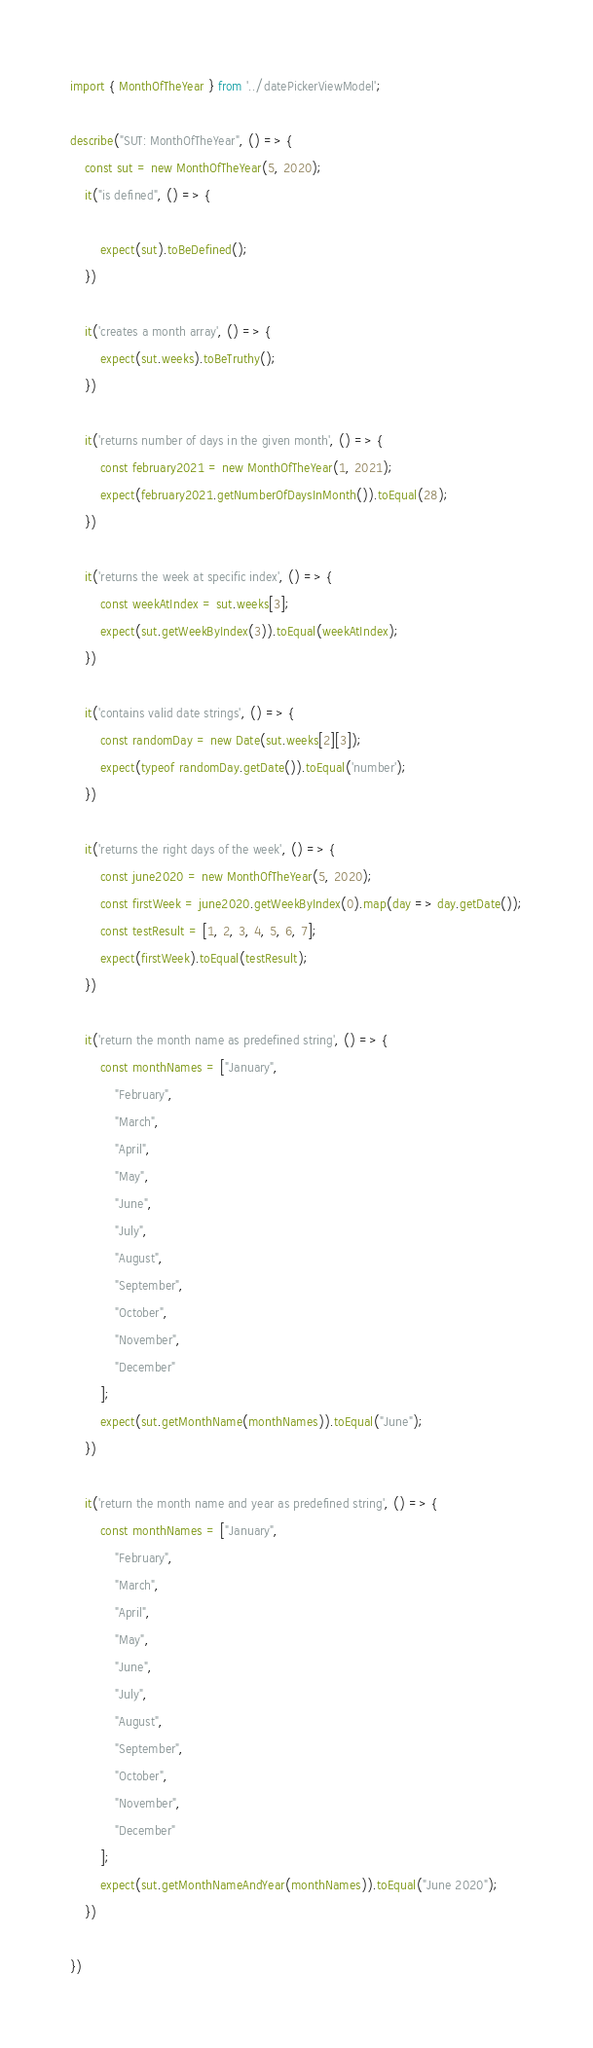<code> <loc_0><loc_0><loc_500><loc_500><_TypeScript_>import { MonthOfTheYear } from '../datePickerViewModel';

describe("SUT: MonthOfTheYear", () => {
    const sut = new MonthOfTheYear(5, 2020);
    it("is defined", () => {

        expect(sut).toBeDefined();
    })

    it('creates a month array', () => {
        expect(sut.weeks).toBeTruthy();
    })

    it('returns number of days in the given month', () => {
        const february2021 = new MonthOfTheYear(1, 2021);
        expect(february2021.getNumberOfDaysInMonth()).toEqual(28);
    })

    it('returns the week at specific index', () => {
        const weekAtIndex = sut.weeks[3];
        expect(sut.getWeekByIndex(3)).toEqual(weekAtIndex);
    })

    it('contains valid date strings', () => {
        const randomDay = new Date(sut.weeks[2][3]);
        expect(typeof randomDay.getDate()).toEqual('number');
    })

    it('returns the right days of the week', () => {
        const june2020 = new MonthOfTheYear(5, 2020);
        const firstWeek = june2020.getWeekByIndex(0).map(day => day.getDate());
        const testResult = [1, 2, 3, 4, 5, 6, 7];
        expect(firstWeek).toEqual(testResult);
    })

    it('return the month name as predefined string', () => {
        const monthNames = ["January",
            "February",
            "March",
            "April",
            "May",
            "June",
            "July",
            "August",
            "September",
            "October",
            "November",
            "December"
        ];
        expect(sut.getMonthName(monthNames)).toEqual("June");
    })

    it('return the month name and year as predefined string', () => {
        const monthNames = ["January",
            "February",
            "March",
            "April",
            "May",
            "June",
            "July",
            "August",
            "September",
            "October",
            "November",
            "December"
        ];
        expect(sut.getMonthNameAndYear(monthNames)).toEqual("June 2020");
    })

})</code> 